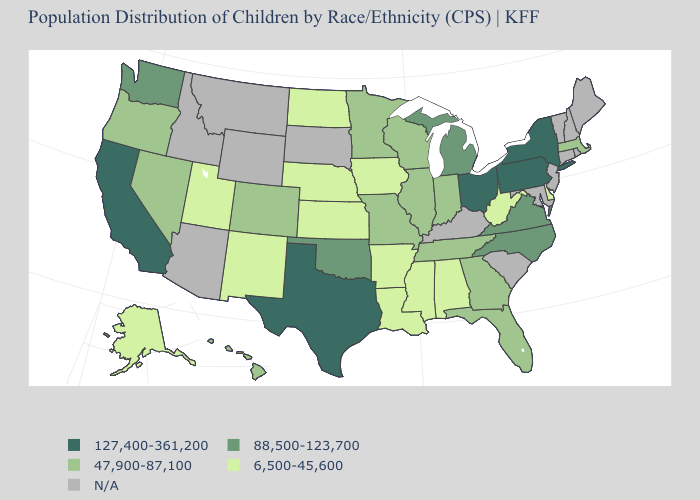Does Colorado have the lowest value in the West?
Short answer required. No. Which states have the highest value in the USA?
Concise answer only. California, New York, Ohio, Pennsylvania, Texas. What is the value of Kentucky?
Write a very short answer. N/A. What is the value of Oklahoma?
Concise answer only. 88,500-123,700. What is the value of Massachusetts?
Answer briefly. 47,900-87,100. Does Indiana have the lowest value in the USA?
Give a very brief answer. No. How many symbols are there in the legend?
Concise answer only. 5. Name the states that have a value in the range 6,500-45,600?
Be succinct. Alabama, Alaska, Arkansas, Delaware, Iowa, Kansas, Louisiana, Mississippi, Nebraska, New Mexico, North Dakota, Utah, West Virginia. Does Oklahoma have the highest value in the USA?
Short answer required. No. Does the first symbol in the legend represent the smallest category?
Give a very brief answer. No. Does the map have missing data?
Keep it brief. Yes. Does the map have missing data?
Concise answer only. Yes. What is the value of Connecticut?
Answer briefly. N/A. 